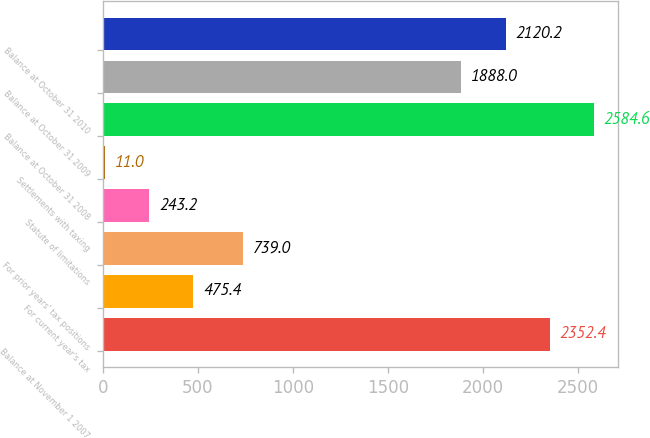Convert chart to OTSL. <chart><loc_0><loc_0><loc_500><loc_500><bar_chart><fcel>Balance at November 1 2007<fcel>For current year's tax<fcel>For prior years' tax positions<fcel>Statute of limitations<fcel>Settlements with taxing<fcel>Balance at October 31 2008<fcel>Balance at October 31 2009<fcel>Balance at October 31 2010<nl><fcel>2352.4<fcel>475.4<fcel>739<fcel>243.2<fcel>11<fcel>2584.6<fcel>1888<fcel>2120.2<nl></chart> 